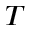<formula> <loc_0><loc_0><loc_500><loc_500>T</formula> 